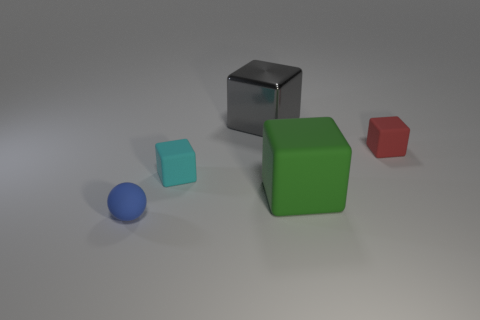Add 1 tiny red objects. How many objects exist? 6 Subtract all brown blocks. Subtract all blue cylinders. How many blocks are left? 4 Subtract all spheres. How many objects are left? 4 Add 2 cyan rubber things. How many cyan rubber things exist? 3 Subtract 0 yellow spheres. How many objects are left? 5 Subtract all gray shiny objects. Subtract all large cylinders. How many objects are left? 4 Add 2 small red blocks. How many small red blocks are left? 3 